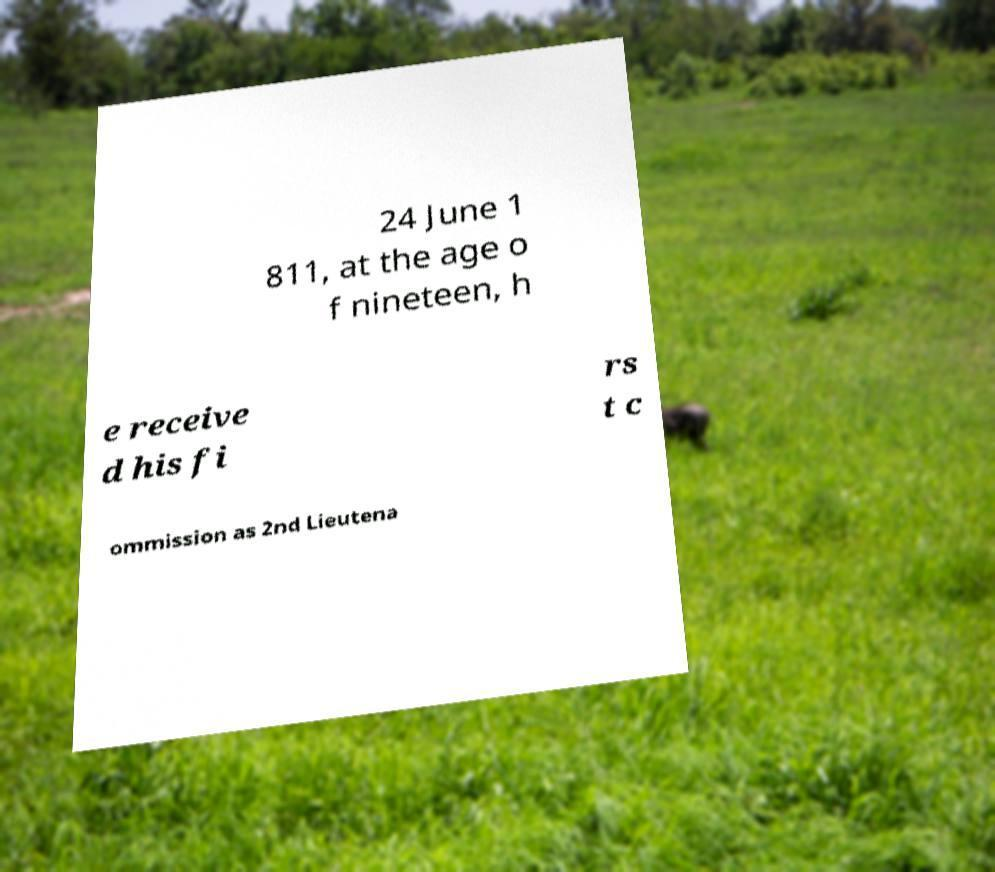What messages or text are displayed in this image? I need them in a readable, typed format. 24 June 1 811, at the age o f nineteen, h e receive d his fi rs t c ommission as 2nd Lieutena 